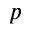Convert formula to latex. <formula><loc_0><loc_0><loc_500><loc_500>p</formula> 